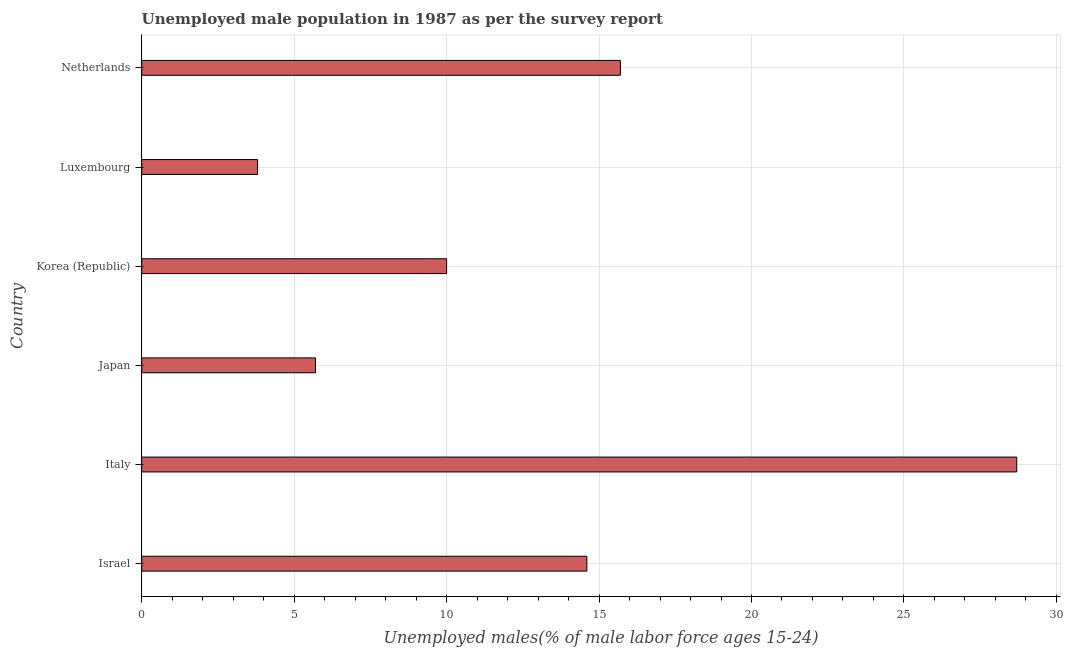What is the title of the graph?
Offer a very short reply. Unemployed male population in 1987 as per the survey report. What is the label or title of the X-axis?
Ensure brevity in your answer.  Unemployed males(% of male labor force ages 15-24). What is the unemployed male youth in Luxembourg?
Make the answer very short. 3.8. Across all countries, what is the maximum unemployed male youth?
Offer a very short reply. 28.7. Across all countries, what is the minimum unemployed male youth?
Your response must be concise. 3.8. In which country was the unemployed male youth minimum?
Offer a terse response. Luxembourg. What is the sum of the unemployed male youth?
Keep it short and to the point. 78.5. What is the average unemployed male youth per country?
Your response must be concise. 13.08. What is the median unemployed male youth?
Your response must be concise. 12.3. In how many countries, is the unemployed male youth greater than 3 %?
Your answer should be compact. 6. What is the ratio of the unemployed male youth in Israel to that in Netherlands?
Offer a very short reply. 0.93. What is the difference between the highest and the second highest unemployed male youth?
Provide a succinct answer. 13. Is the sum of the unemployed male youth in Italy and Korea (Republic) greater than the maximum unemployed male youth across all countries?
Offer a terse response. Yes. What is the difference between the highest and the lowest unemployed male youth?
Your answer should be compact. 24.9. How many bars are there?
Provide a short and direct response. 6. What is the difference between two consecutive major ticks on the X-axis?
Make the answer very short. 5. Are the values on the major ticks of X-axis written in scientific E-notation?
Your answer should be compact. No. What is the Unemployed males(% of male labor force ages 15-24) of Israel?
Your response must be concise. 14.6. What is the Unemployed males(% of male labor force ages 15-24) in Italy?
Offer a terse response. 28.7. What is the Unemployed males(% of male labor force ages 15-24) of Japan?
Keep it short and to the point. 5.7. What is the Unemployed males(% of male labor force ages 15-24) in Luxembourg?
Provide a succinct answer. 3.8. What is the Unemployed males(% of male labor force ages 15-24) of Netherlands?
Your answer should be very brief. 15.7. What is the difference between the Unemployed males(% of male labor force ages 15-24) in Israel and Italy?
Make the answer very short. -14.1. What is the difference between the Unemployed males(% of male labor force ages 15-24) in Israel and Japan?
Your response must be concise. 8.9. What is the difference between the Unemployed males(% of male labor force ages 15-24) in Italy and Luxembourg?
Your response must be concise. 24.9. What is the difference between the Unemployed males(% of male labor force ages 15-24) in Italy and Netherlands?
Offer a very short reply. 13. What is the difference between the Unemployed males(% of male labor force ages 15-24) in Luxembourg and Netherlands?
Keep it short and to the point. -11.9. What is the ratio of the Unemployed males(% of male labor force ages 15-24) in Israel to that in Italy?
Provide a short and direct response. 0.51. What is the ratio of the Unemployed males(% of male labor force ages 15-24) in Israel to that in Japan?
Your answer should be compact. 2.56. What is the ratio of the Unemployed males(% of male labor force ages 15-24) in Israel to that in Korea (Republic)?
Ensure brevity in your answer.  1.46. What is the ratio of the Unemployed males(% of male labor force ages 15-24) in Israel to that in Luxembourg?
Offer a terse response. 3.84. What is the ratio of the Unemployed males(% of male labor force ages 15-24) in Italy to that in Japan?
Offer a terse response. 5.04. What is the ratio of the Unemployed males(% of male labor force ages 15-24) in Italy to that in Korea (Republic)?
Ensure brevity in your answer.  2.87. What is the ratio of the Unemployed males(% of male labor force ages 15-24) in Italy to that in Luxembourg?
Provide a short and direct response. 7.55. What is the ratio of the Unemployed males(% of male labor force ages 15-24) in Italy to that in Netherlands?
Your answer should be very brief. 1.83. What is the ratio of the Unemployed males(% of male labor force ages 15-24) in Japan to that in Korea (Republic)?
Your answer should be very brief. 0.57. What is the ratio of the Unemployed males(% of male labor force ages 15-24) in Japan to that in Netherlands?
Make the answer very short. 0.36. What is the ratio of the Unemployed males(% of male labor force ages 15-24) in Korea (Republic) to that in Luxembourg?
Provide a short and direct response. 2.63. What is the ratio of the Unemployed males(% of male labor force ages 15-24) in Korea (Republic) to that in Netherlands?
Offer a terse response. 0.64. What is the ratio of the Unemployed males(% of male labor force ages 15-24) in Luxembourg to that in Netherlands?
Your answer should be compact. 0.24. 